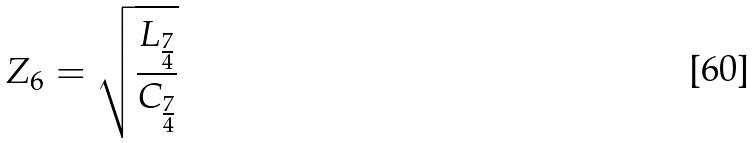Convert formula to latex. <formula><loc_0><loc_0><loc_500><loc_500>Z _ { 6 } = \sqrt { \frac { L _ { \frac { 7 } { 4 } } } { C _ { \frac { 7 } { 4 } } } }</formula> 